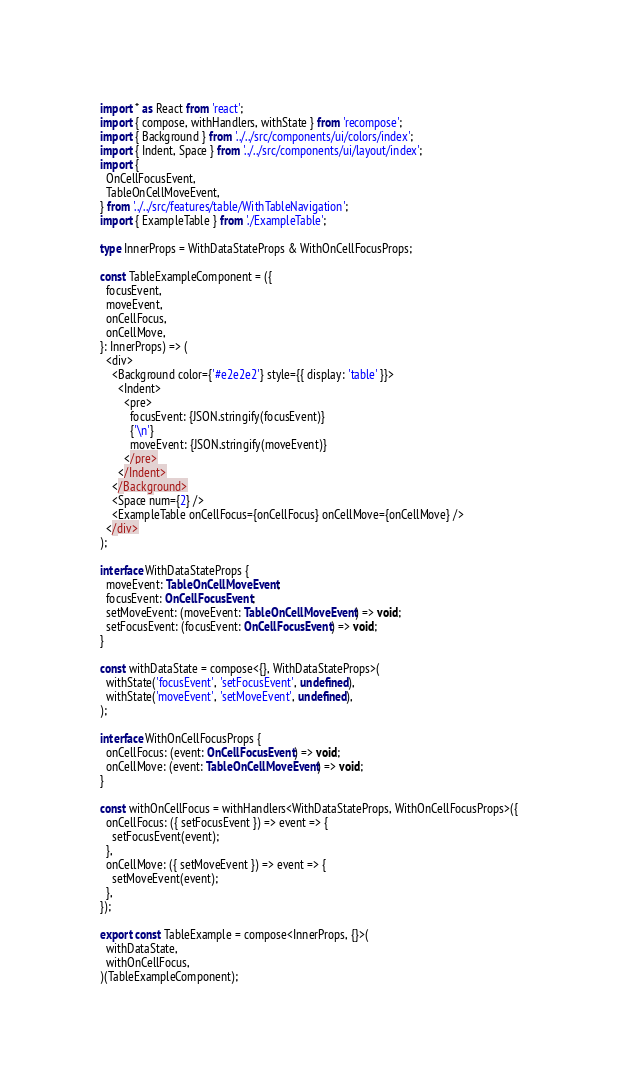Convert code to text. <code><loc_0><loc_0><loc_500><loc_500><_TypeScript_>import * as React from 'react';
import { compose, withHandlers, withState } from 'recompose';
import { Background } from '../../src/components/ui/colors/index';
import { Indent, Space } from '../../src/components/ui/layout/index';
import {
  OnCellFocusEvent,
  TableOnCellMoveEvent,
} from '../../src/features/table/WithTableNavigation';
import { ExampleTable } from './ExampleTable';

type InnerProps = WithDataStateProps & WithOnCellFocusProps;

const TableExampleComponent = ({
  focusEvent,
  moveEvent,
  onCellFocus,
  onCellMove,
}: InnerProps) => (
  <div>
    <Background color={'#e2e2e2'} style={{ display: 'table' }}>
      <Indent>
        <pre>
          focusEvent: {JSON.stringify(focusEvent)}
          {'\n'}
          moveEvent: {JSON.stringify(moveEvent)}
        </pre>
      </Indent>
    </Background>
    <Space num={2} />
    <ExampleTable onCellFocus={onCellFocus} onCellMove={onCellMove} />
  </div>
);

interface WithDataStateProps {
  moveEvent: TableOnCellMoveEvent;
  focusEvent: OnCellFocusEvent;
  setMoveEvent: (moveEvent: TableOnCellMoveEvent) => void;
  setFocusEvent: (focusEvent: OnCellFocusEvent) => void;
}

const withDataState = compose<{}, WithDataStateProps>(
  withState('focusEvent', 'setFocusEvent', undefined),
  withState('moveEvent', 'setMoveEvent', undefined),
);

interface WithOnCellFocusProps {
  onCellFocus: (event: OnCellFocusEvent) => void;
  onCellMove: (event: TableOnCellMoveEvent) => void;
}

const withOnCellFocus = withHandlers<WithDataStateProps, WithOnCellFocusProps>({
  onCellFocus: ({ setFocusEvent }) => event => {
    setFocusEvent(event);
  },
  onCellMove: ({ setMoveEvent }) => event => {
    setMoveEvent(event);
  },
});

export const TableExample = compose<InnerProps, {}>(
  withDataState,
  withOnCellFocus,
)(TableExampleComponent);
</code> 